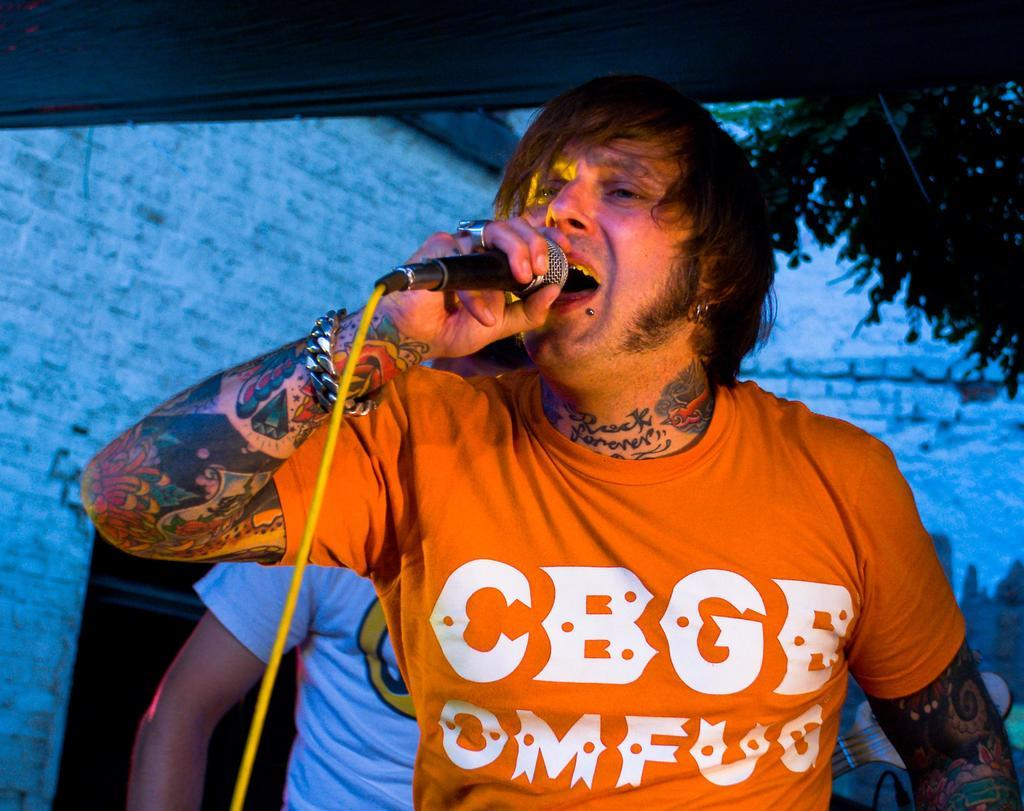What is the person in the foreground of the image holding? The person is holding a microphone in the image. Can you describe the other person in the image? There is another person in the background of the image. What can be seen on the right side of the image? There is a tree on the right side of the image. What type of power source is visible in the image? There is no power source visible in the image. Can you describe the ghost that is present in the image? There is no ghost present in the image. 